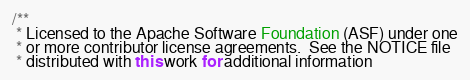Convert code to text. <code><loc_0><loc_0><loc_500><loc_500><_Java_>/**
 * Licensed to the Apache Software Foundation (ASF) under one
 * or more contributor license agreements.  See the NOTICE file
 * distributed with this work for additional information</code> 